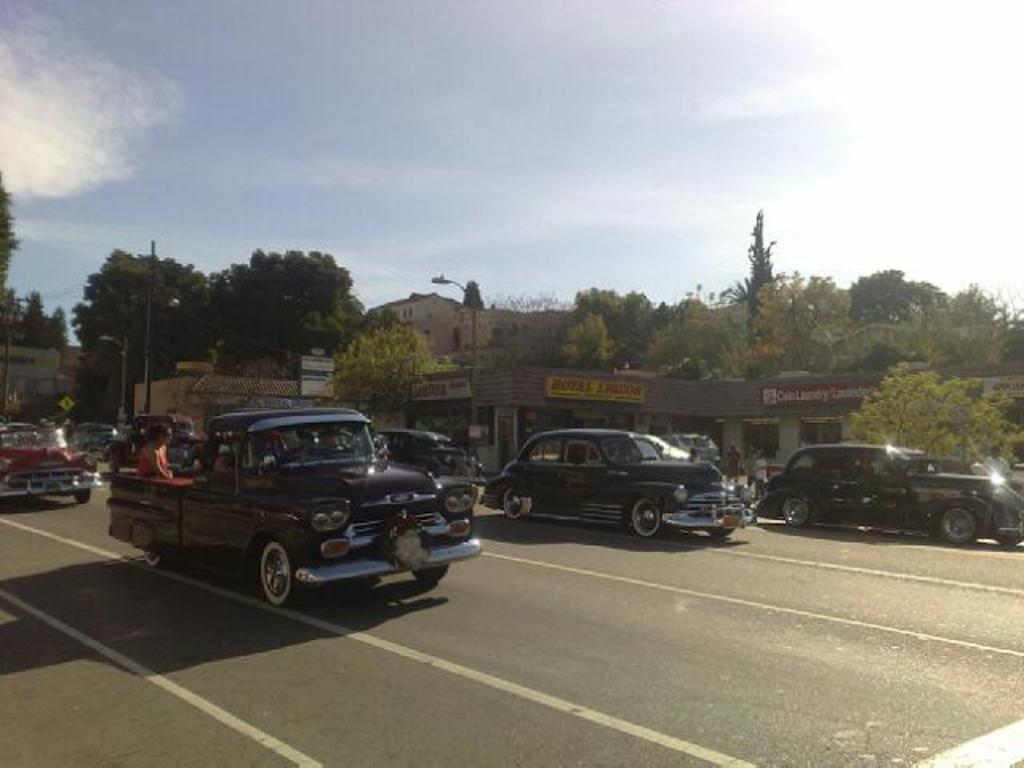What is happening on the road in the image? There are vehicles moving on the road in the image. What type of natural elements can be seen in the image? Trees are visible in the image. What type of structures are present in the image? There are houses in the image. What type of man-made objects can be seen in the image? There are light poles in the image. What is visible in the background of the image? The sky is visible in the background of the image. What can be seen in the sky? Clouds are present in the sky. What type of grain is being harvested by the partner in the image? There is no partner or grain present in the image. How does the competition affect the vehicles on the road in the image? There is no competition present in the image; it simply shows vehicles moving on the road. 